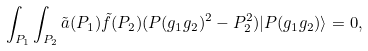<formula> <loc_0><loc_0><loc_500><loc_500>\int _ { P _ { 1 } } \int _ { P _ { 2 } } \tilde { a } ( P _ { 1 } ) \tilde { f } ( P _ { 2 } ) ( P ( g _ { 1 } g _ { 2 } ) ^ { 2 } - P _ { 2 } ^ { 2 } ) | P ( g _ { 1 } g _ { 2 } ) \rangle = 0 ,</formula> 